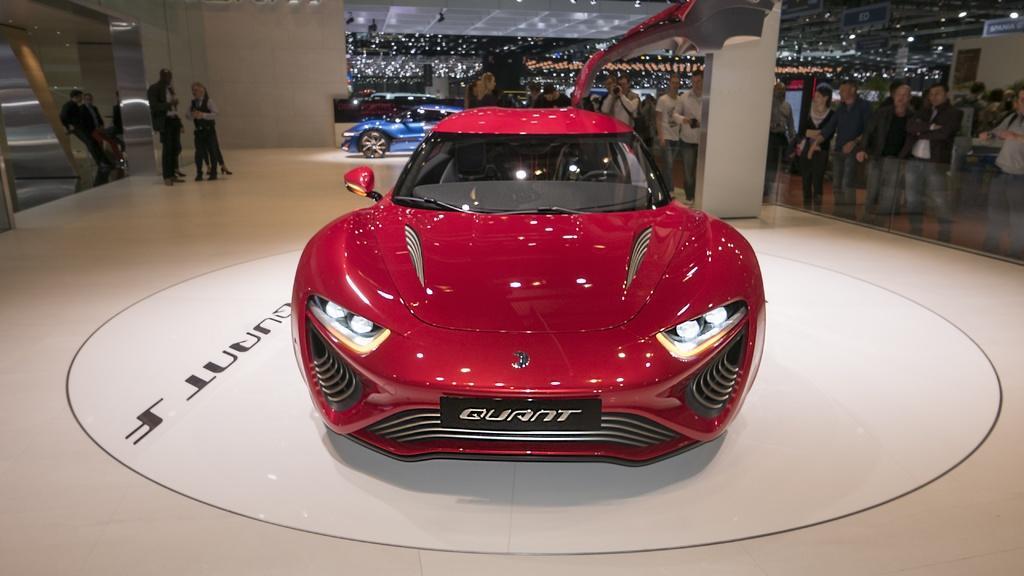In one or two sentences, can you explain what this image depicts? In this image I can see a red colour car in the front and on the front side of the car I can see something is written. On the left side of this image I can see something is written on the floor. In the background I can see few vehicles, number of lights and I can also see number of people are standing. On the top right side of this image I can see a blue colour board and on it I can see something is written. 